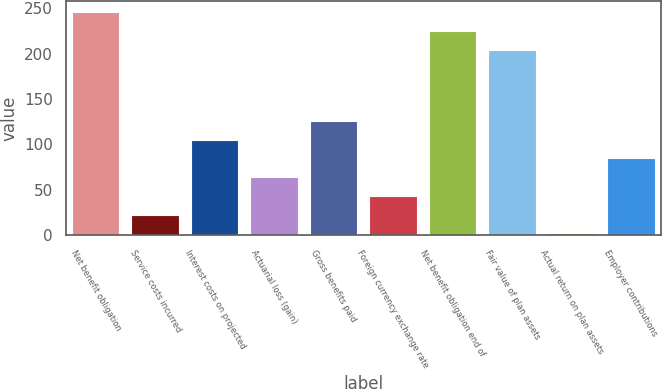Convert chart to OTSL. <chart><loc_0><loc_0><loc_500><loc_500><bar_chart><fcel>Net benefit obligation<fcel>Service costs incurred<fcel>Interest costs on projected<fcel>Actuarial loss (gain)<fcel>Gross benefits paid<fcel>Foreign currency exchange rate<fcel>Net benefit obligation end of<fcel>Fair value of plan assets<fcel>Actual return on plan assets<fcel>Employer contributions<nl><fcel>245.9<fcel>22.3<fcel>105.1<fcel>63.7<fcel>125.8<fcel>43<fcel>225.2<fcel>204.5<fcel>1.6<fcel>84.4<nl></chart> 